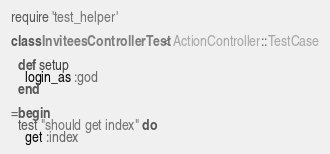Convert code to text. <code><loc_0><loc_0><loc_500><loc_500><_Ruby_>require 'test_helper'

class InviteesControllerTest < ActionController::TestCase

  def setup
    login_as :god
  end

=begin
  test "should get index" do
    get :index</code> 